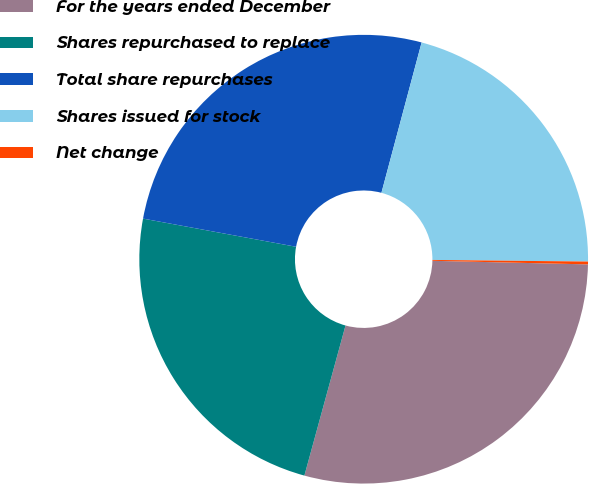Convert chart to OTSL. <chart><loc_0><loc_0><loc_500><loc_500><pie_chart><fcel>For the years ended December<fcel>Shares repurchased to replace<fcel>Total share repurchases<fcel>Shares issued for stock<fcel>Net change<nl><fcel>28.89%<fcel>23.64%<fcel>26.26%<fcel>21.01%<fcel>0.2%<nl></chart> 